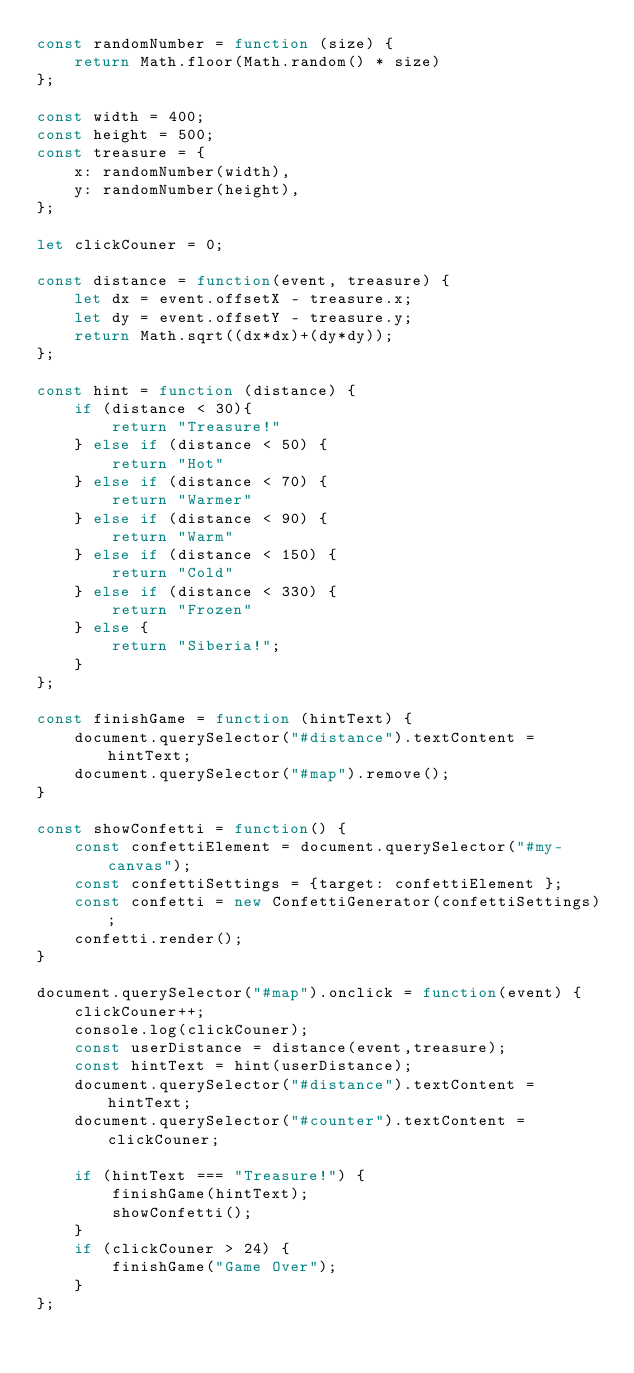<code> <loc_0><loc_0><loc_500><loc_500><_JavaScript_>const randomNumber = function (size) {
    return Math.floor(Math.random() * size)
};

const width = 400;
const height = 500;
const treasure = {
    x: randomNumber(width),
    y: randomNumber(height),
};

let clickCouner = 0;

const distance = function(event, treasure) {
    let dx = event.offsetX - treasure.x; 
    let dy = event.offsetY - treasure.y; 
    return Math.sqrt((dx*dx)+(dy*dy));
};

const hint = function (distance) {
    if (distance < 30){
        return "Treasure!"
    } else if (distance < 50) {
        return "Hot"
    } else if (distance < 70) {
        return "Warmer"
    } else if (distance < 90) {
        return "Warm"
    } else if (distance < 150) {
        return "Cold"
    } else if (distance < 330) {
        return "Frozen"
    } else {
        return "Siberia!";
    }
};

const finishGame = function (hintText) {
    document.querySelector("#distance").textContent = hintText;
    document.querySelector("#map").remove();
}

const showConfetti = function() {
    const confettiElement = document.querySelector("#my-canvas");
    const confettiSettings = {target: confettiElement };
    const confetti = new ConfettiGenerator(confettiSettings);
    confetti.render();
}

document.querySelector("#map").onclick = function(event) {
    clickCouner++;
    console.log(clickCouner);
    const userDistance = distance(event,treasure);
    const hintText = hint(userDistance);
    document.querySelector("#distance").textContent = hintText;
    document.querySelector("#counter").textContent = clickCouner;
    
    if (hintText === "Treasure!") {
        finishGame(hintText);
        showConfetti();
    }
    if (clickCouner > 24) {
        finishGame("Game Over");
    }
};
</code> 